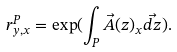<formula> <loc_0><loc_0><loc_500><loc_500>r ^ { P } _ { y , x } = \exp ( \int _ { P } \vec { A } ( z ) _ { x } \vec { d z } ) .</formula> 